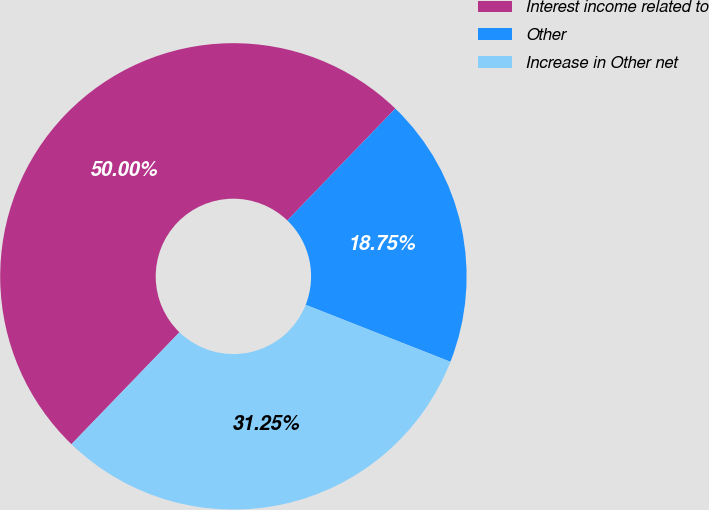Convert chart to OTSL. <chart><loc_0><loc_0><loc_500><loc_500><pie_chart><fcel>Interest income related to<fcel>Other<fcel>Increase in Other net<nl><fcel>50.0%<fcel>18.75%<fcel>31.25%<nl></chart> 